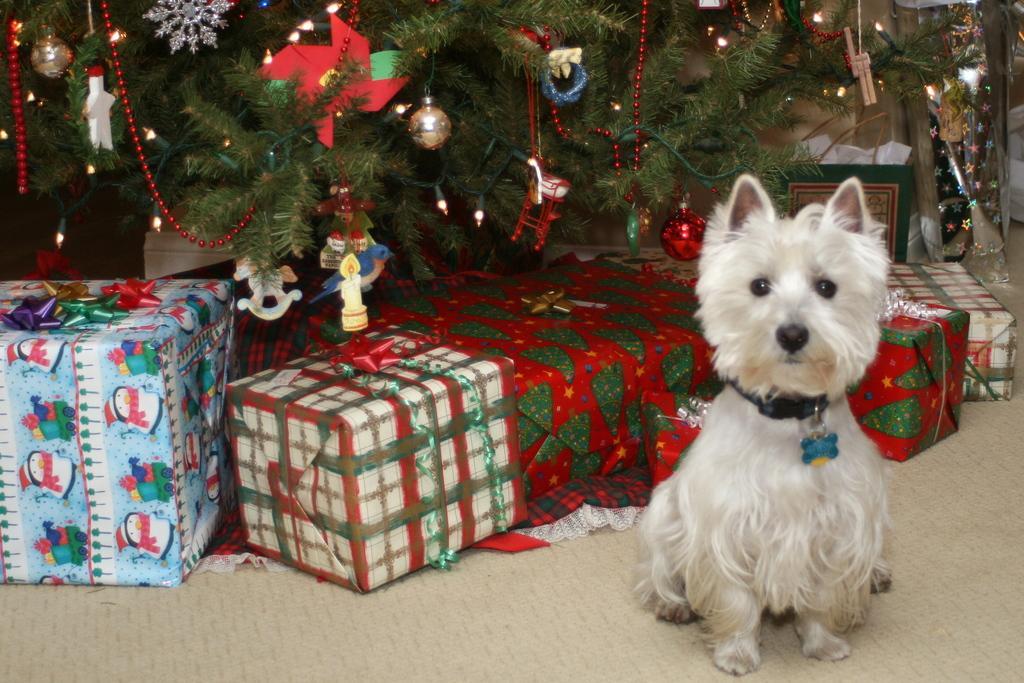Please provide a concise description of this image. In this image I can see a Christmas tree. I can see balls,toys and some object on the tree. I can see few gifts. They are in different color. In front I can see a white color dog. 